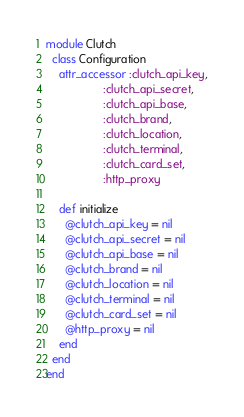<code> <loc_0><loc_0><loc_500><loc_500><_Ruby_>module Clutch
  class Configuration
    attr_accessor :clutch_api_key,
                  :clutch_api_secret,
                  :clutch_api_base,
                  :clutch_brand,
                  :clutch_location,
                  :clutch_terminal,
                  :clutch_card_set,
                  :http_proxy

    def initialize
      @clutch_api_key = nil
      @clutch_api_secret = nil
      @clutch_api_base = nil
      @clutch_brand = nil
      @clutch_location = nil
      @clutch_terminal = nil
      @clutch_card_set = nil
      @http_proxy = nil
    end
  end
end
</code> 